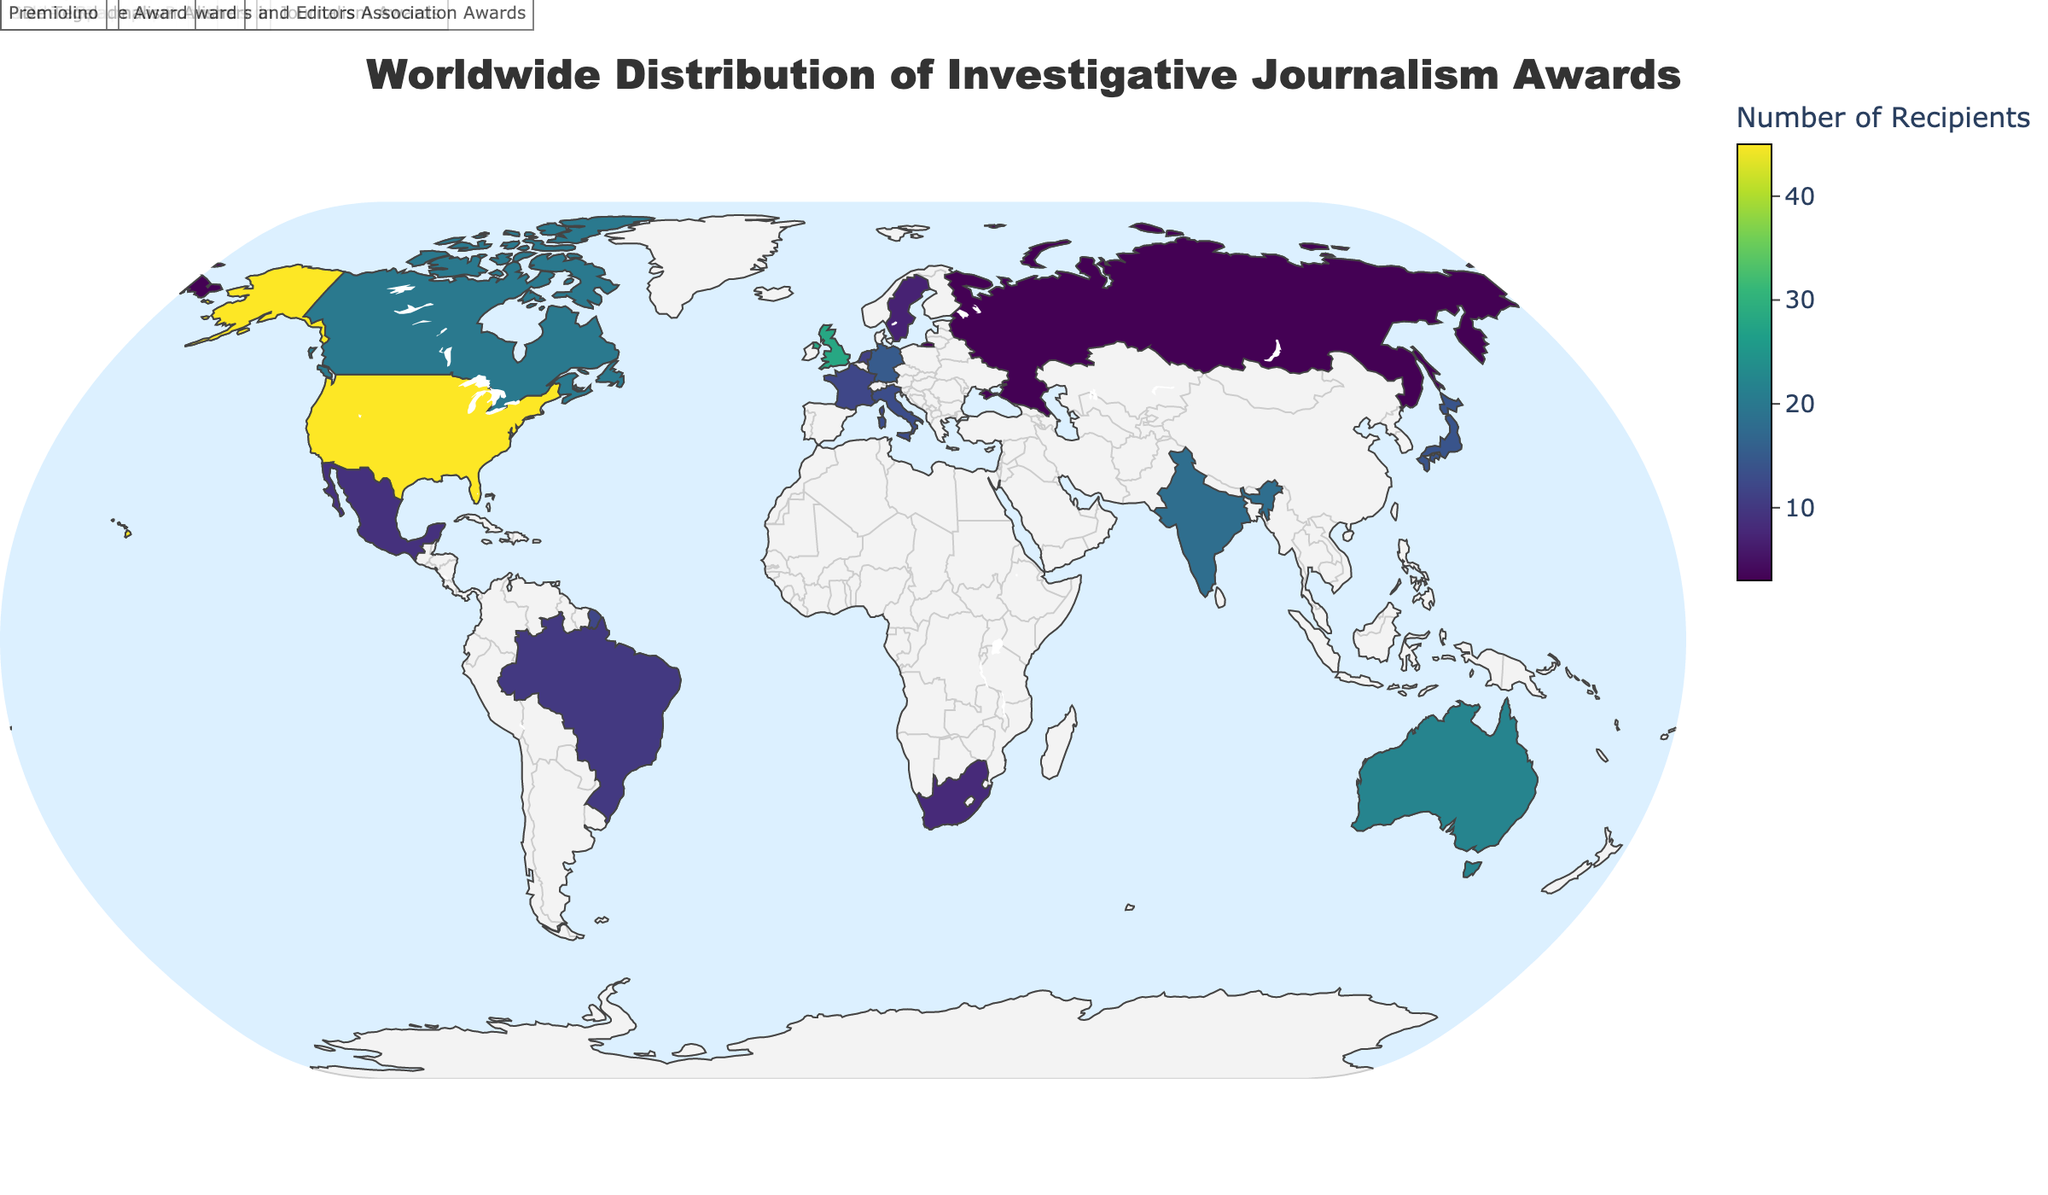What is the title of the figure? The title of the figure is displayed prominently at the top, just below the country names. It reads "Worldwide Distribution of Investigative Journalism Awards".
Answer: Worldwide Distribution of Investigative Journalism Awards Which country has the highest number of investigative journalism award recipients? By looking at the color intensity on the map and the hover data, the United States has the highest number of recipients with a total of 45.
Answer: United States What is the name of the award given in France? By hovering over France on the map, the displayed data shows that the name of the award given in France is the Albert Londres Prize.
Answer: Albert Londres Prize How many total awards are given out in Australia and Canada combined? Identifying Australia and Canada on the map and adding the number of recipients, Australia has 22 recipients and Canada has 20 recipients. Therefore, the total is 22 + 20 = 42.
Answer: 42 How does the number of Pulitzer Prize recipients compare to the number of Walkley Awards recipients? The map displays the United States for Pulitzer Prizes with 45 recipients and Australia for Walkley Awards with 22 recipients. By comparing these numbers, the United States has more recipients than Australia.
Answer: The United States has more recipients Which countries have fewer than 10 award recipients? By analyzing the map and data points, the countries with fewer than 10 award recipients are South Africa, Russia, Mexico, and Sweden, having 8, 3, 9, and 7 recipients, respectively.
Answer: South Africa, Russia, Mexico, Sweden What can be said about the geographical distribution of investigative journalism awards in terms of continents? Examining the map, it is noticeable that investigative journalism awards are distributed across multiple continents, including North America (United States, Canada, Mexico), Europe (United Kingdom, Germany, France, Sweden, Netherlands, Italy), Asia (India, Japan), Africa (South Africa), Australia, and South America (Brazil).
Answer: Awards are distributed across multiple continents 